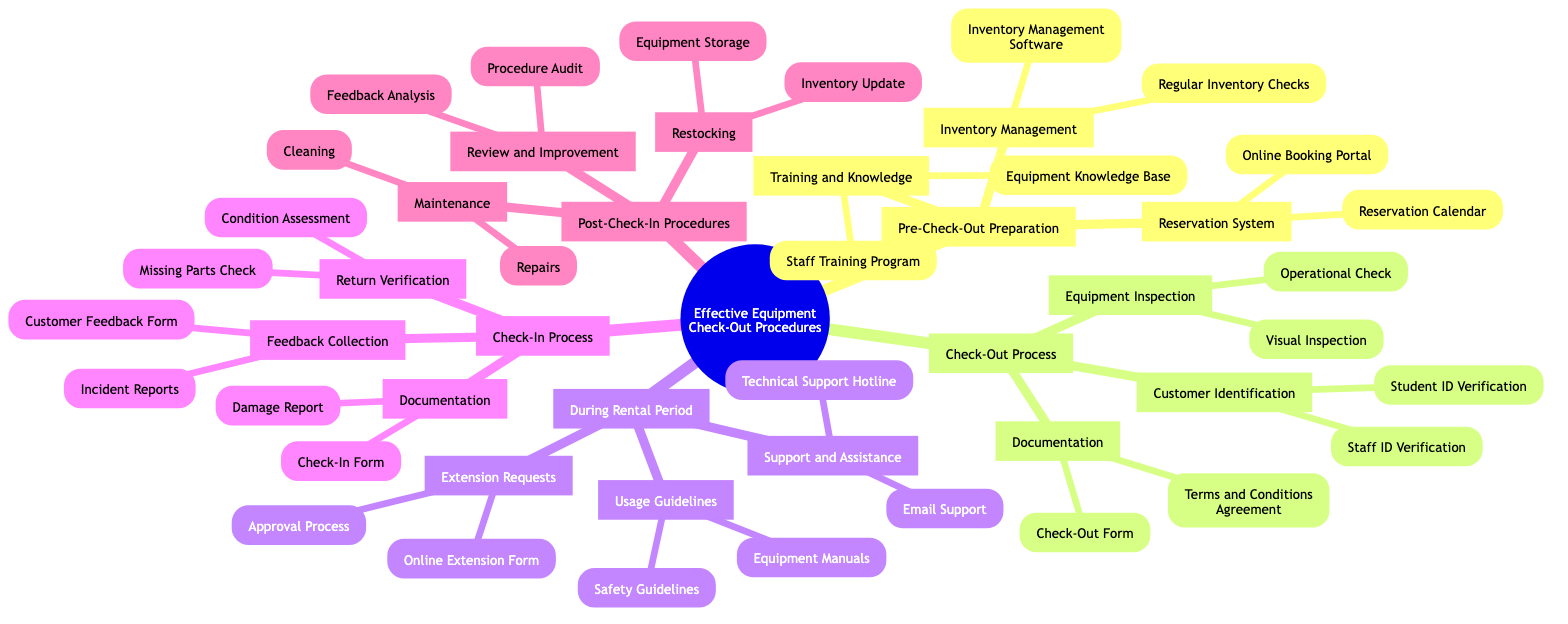What is the first main category in the diagram? The diagram lists "Effective Equipment Check-Out Procedures" as the main title, and the first main category under this title is "Pre-Check-Out Preparation."
Answer: Pre-Check-Out Preparation How many subcategories are there under the "Check-In Process"? The "Check-In Process" category contains three subcategories: "Return Verification," "Documentation," and "Feedback Collection." Therefore, the number of subcategories is three.
Answer: 3 What process is associated with the "Equipment Inspection"? The "Equipment Inspection" subcategory falls under the main category "Check-Out Process," specifically mentioning two processes: "Visual Inspection" and "Operational Check."
Answer: Visual Inspection, Operational Check Which method is listed for customer identification during the check-out process? The diagram shows two methods under "Customer Identification": "Student ID Verification" and "Staff ID Verification." Both are means to identify customers during check-out.
Answer: Student ID Verification, Staff ID Verification What is the purpose of the "Online Booking Portal"? The "Online Booking Portal" is listed under "Reservation System," indicating its role in managing equipment reservations. It serves the purpose of enabling customers to book equipment online.
Answer: Equipment reservations How many steps are involved in the "During Rental Period"? The section "During Rental Period" has three steps: "Support and Assistance," "Usage Guidelines," and "Extension Requests." Counting these, we see there are three steps involved.
Answer: 3 What are the types of documentation needed during the check-in process? The documentation needed during check-in, as detailed in the diagram, consists of two types: the "Check-In Form" and the "Damage Report." These documents are essential for the check-in process.
Answer: Check-In Form, Damage Report In which category would you find the "Technical Support Hotline"? The "Technical Support Hotline" is listed under the "Support and Assistance" subsection, which falls within the larger category named "During Rental Period." This indicates its function in assisting customers during their rental time.
Answer: During Rental Period What action follows the "Condition Assessment" in the Check-In Process? Following the "Condition Assessment," the next action outlined in the Check-In Process is the "Missing Parts Check," which entails verifying the completeness of returned equipment.
Answer: Missing Parts Check What is a key feature of the "Post-Check-In Procedures"? The "Post-Check-In Procedures" consist of several features including "Maintenance," "Restocking," and "Review and Improvement," indicating the actions taken after checking in equipment.
Answer: Maintenance, Restocking, Review and Improvement 